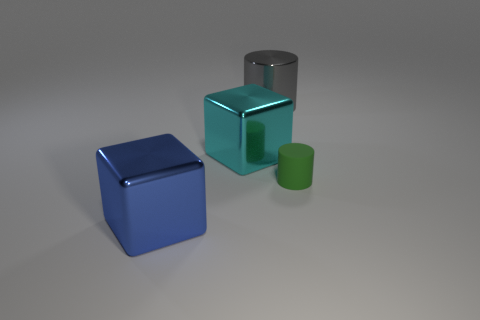Is the number of green metal cylinders greater than the number of green cylinders?
Make the answer very short. No. Is there anything else that has the same color as the big metallic cylinder?
Provide a short and direct response. No. What is the size of the cylinder that is made of the same material as the large cyan block?
Ensure brevity in your answer.  Large. What is the material of the large blue thing?
Provide a short and direct response. Metal. What number of brown spheres have the same size as the metallic cylinder?
Offer a very short reply. 0. Is there a small red object of the same shape as the cyan shiny object?
Make the answer very short. No. There is a cube that is the same size as the cyan shiny thing; what color is it?
Ensure brevity in your answer.  Blue. There is a shiny cube on the left side of the large cyan metal thing that is left of the tiny green rubber object; what color is it?
Your answer should be compact. Blue. Is the color of the cylinder left of the small green cylinder the same as the small cylinder?
Offer a terse response. No. There is a thing behind the big shiny block that is right of the block that is in front of the cyan shiny cube; what is its shape?
Ensure brevity in your answer.  Cylinder. 